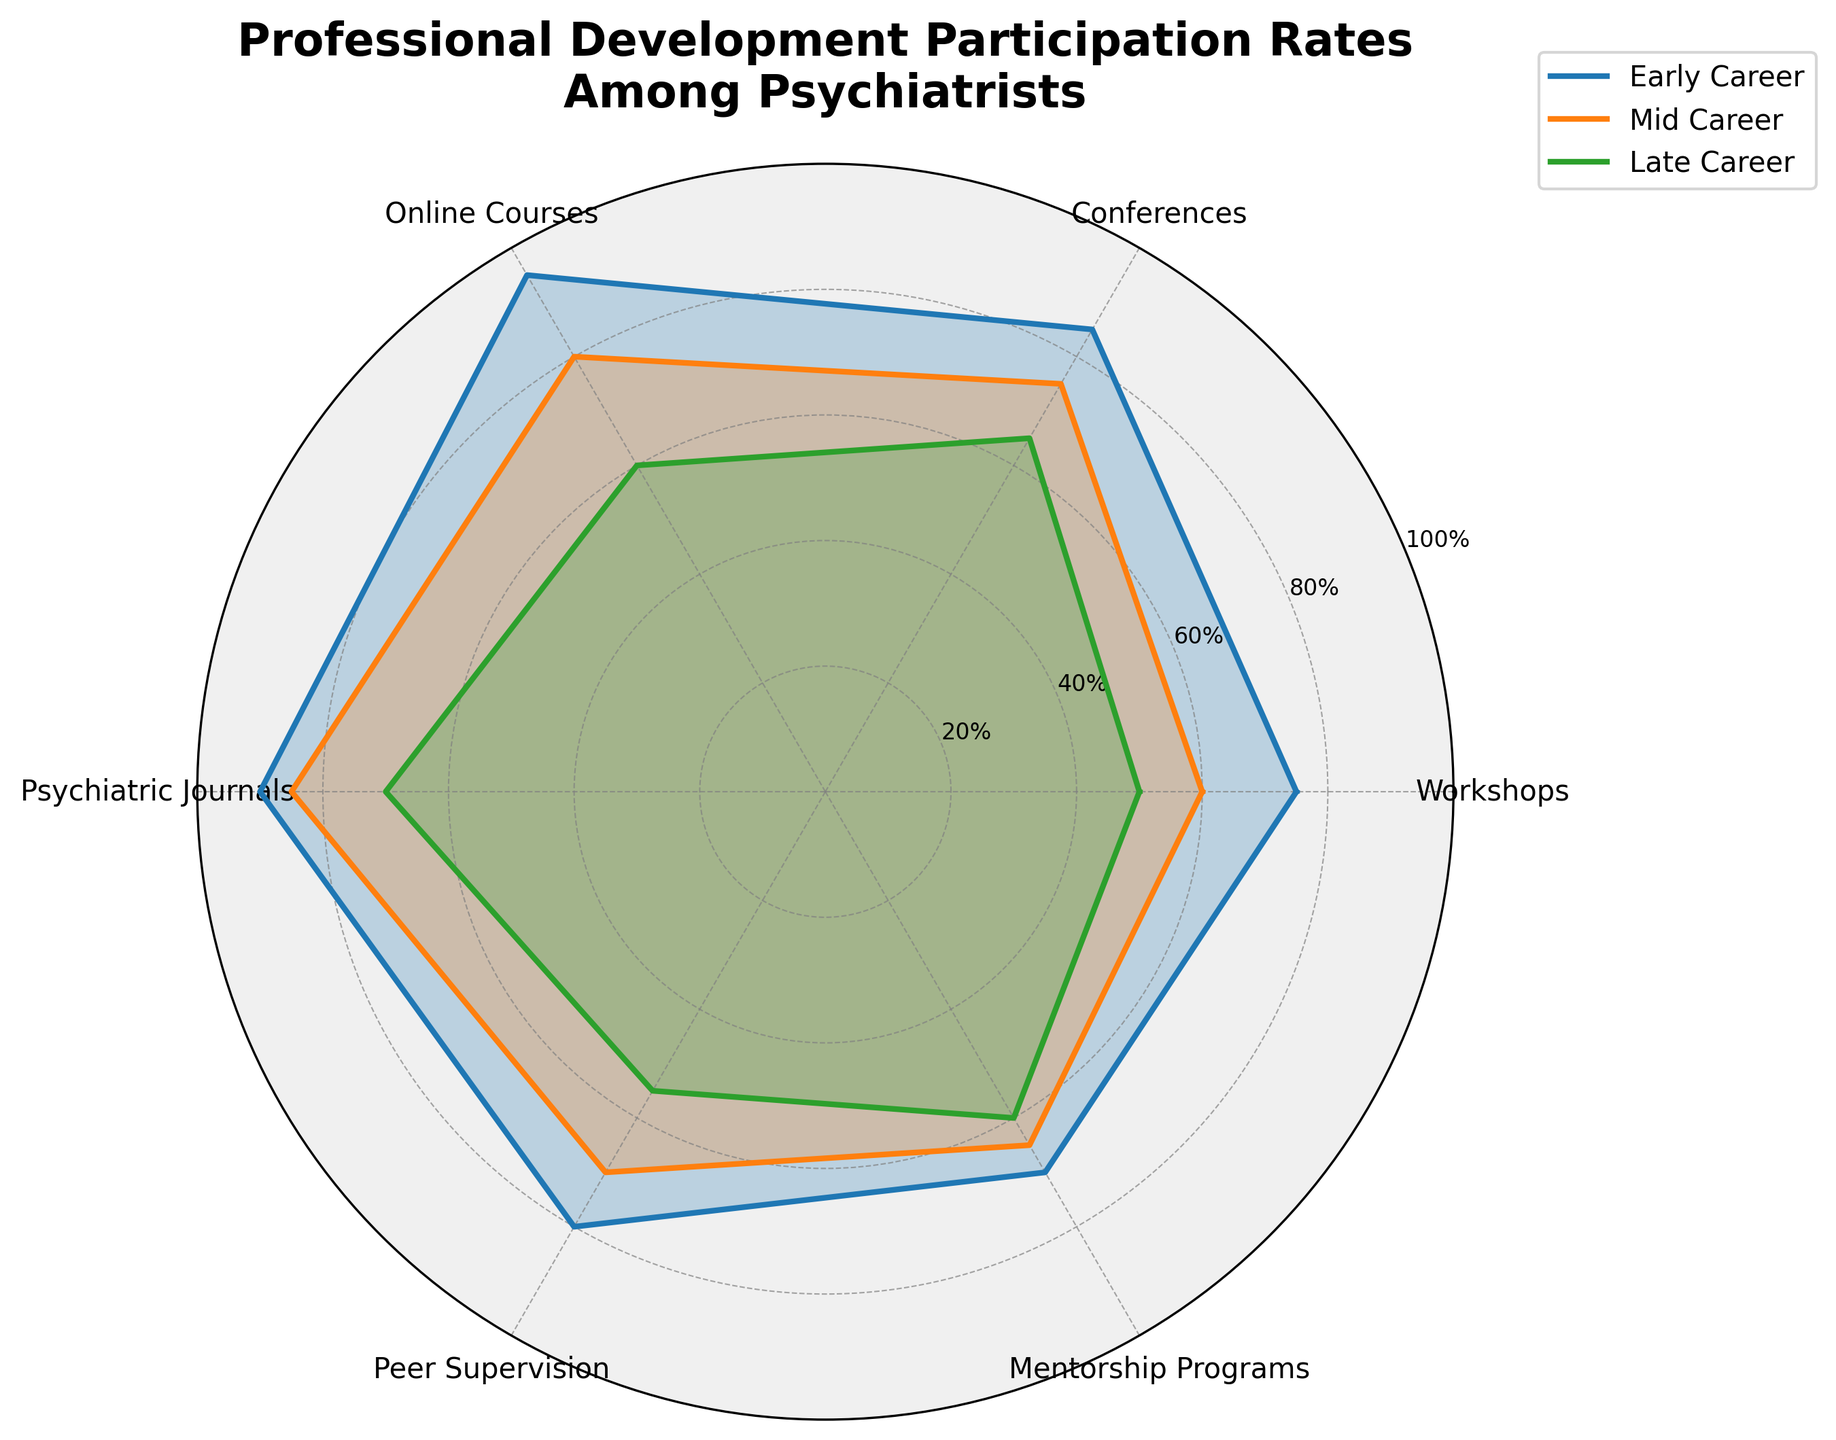What is the title of the figure? The title is located at the top of the figure. It is typically displayed in bold and provides a summary of what the figure represents.
Answer: Professional Development Participation Rates Among Psychiatrists Which career stage participates the most in online courses? Find the highest value in the section labeled 'Online Courses' across all career stages.
Answer: Early Career What is the difference in conference participation rates between early career and late career psychiatrists? Locate the values for 'Conferences' for both early and late career stages, then subtract the late career value from the early career value: 85 - 65 = 20.
Answer: 20 Which professional development activity has the least participation rate among late career psychiatrists? Identify the smallest value in the 'Late Career' data row.
Answer: Online Courses Compare the mentorship program participation rates between early and mid-career stages. Which one is higher? Compare the values for 'Mentorship Programs' for early and mid-career stages: 70 (early) vs. 65 (mid).
Answer: Early Career What is the average participation rate in peer supervision across all career stages? Sum up the 'Peer Supervision' rates for all career stages and divide by the number of career stages: (80 + 70 + 55) / 3 = 68.33.
Answer: 68.33 Which professional development activity has the greatest range of participation rates across the different career stages? Calculate the range for each activity by subtracting the smallest value from the largest value for each activity, then identify the maximum range: Workshops: 75-50 = 25, Conferences: 85-65 = 20, Online Courses: 95-60 = 35, Psychiatric Journals: 90-70 = 20, Peer Supervision: 80-55 = 25, Mentorship Programs: 70-60 = 10.
Answer: Online Courses How does the participation rate in psychiatric journals for mid-career psychiatrists compare to that of early career psychiatrists? Compare the values for 'Psychiatric Journals' between mid and early career stages: 85 (mid) vs. 90 (early).
Answer: Lower What is the total participation rate percentage for late-career psychiatrists across all activities? Sum all the participation rates for 'Late Career': 50 + 65 + 60 + 70 + 55 + 60 = 360.
Answer: 360 In which area do early-career psychiatrists have the smallest margin over mid-career psychiatrists? Subtract the mid-career participation rate from the early-career participation rate for each category, then identify the smallest margin: Workshops: 75-60=15, Conferences: 85-75=10, Online Courses: 95-80=15, Psychiatric Journals: 90-85=5, Peer Supervision: 80-70=10, Mentorship Programs: 70-65=5.
Answer: Psychiatric Journals and Mentorship Programs 